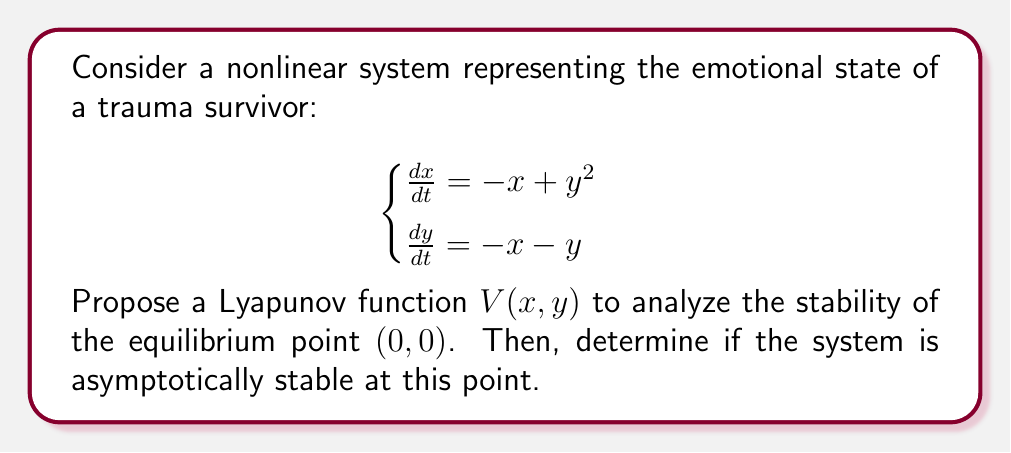Can you solve this math problem? 1. First, we propose a Lyapunov function. Given the structure of the system, a suitable choice is:

   $$V(x,y) = x^2 + y^2$$

2. To prove stability, we need to show that $V(x,y) > 0$ for all $(x,y) \neq (0,0)$ and $V(0,0) = 0$. This is clearly satisfied by our chosen function.

3. Next, we calculate the time derivative of $V$ along the trajectories of the system:

   $$\begin{align}
   \frac{dV}{dt} &= 2x\frac{dx}{dt} + 2y\frac{dy}{dt} \\
   &= 2x(-x+y^2) + 2y(-x-y) \\
   &= -2x^2 + 2xy^2 - 2xy - 2y^2 \\
   &= -2x^2 - 2y^2 + 2xy(y-1)
   \end{align}$$

4. To prove asymptotic stability, we need to show that $\frac{dV}{dt} < 0$ for all $(x,y) \neq (0,0)$. Let's analyze the terms:
   - $-2x^2 - 2y^2$ is always negative for $(x,y) \neq (0,0)$
   - $2xy(y-1)$ could be positive or negative

5. We can rewrite $\frac{dV}{dt}$ as:

   $$\frac{dV}{dt} = -2(x^2 + y^2 - xy(y-1))$$

6. Using the inequality $2ab \leq a^2 + b^2$, we can show that:

   $$xy(y-1) \leq \frac{1}{2}(x^2 + (y(y-1))^2) = \frac{1}{2}(x^2 + y^4 - 2y^3 + y^2)$$

7. Substituting this into our expression for $\frac{dV}{dt}$:

   $$\frac{dV}{dt} \leq -2(x^2 + y^2 - \frac{1}{2}(x^2 + y^4 - 2y^3 + y^2))$$
   $$= -2(\frac{1}{2}x^2 + \frac{1}{2}y^2 - \frac{1}{2}y^4 + y^3)$$
   $$= -(x^2 + y^2 - y^4 + 2y^3)$$
   $$= -(x^2 + y^2(1-y+2))$$
   $$= -(x^2 + y^2(3-y))$$

8. For all $(x,y)$ in a neighborhood of $(0,0)$, we have $y < 3$, so $y^2(3-y) > 0$. Therefore, $\frac{dV}{dt} < 0$ for all $(x,y) \neq (0,0)$ in this neighborhood.

9. Since $V(x,y) > 0$ for all $(x,y) \neq (0,0)$, $V(0,0) = 0$, and $\frac{dV}{dt} < 0$ for all $(x,y) \neq (0,0)$ in a neighborhood of $(0,0)$, we can conclude that the equilibrium point $(0,0)$ is asymptotically stable.
Answer: Asymptotically stable 